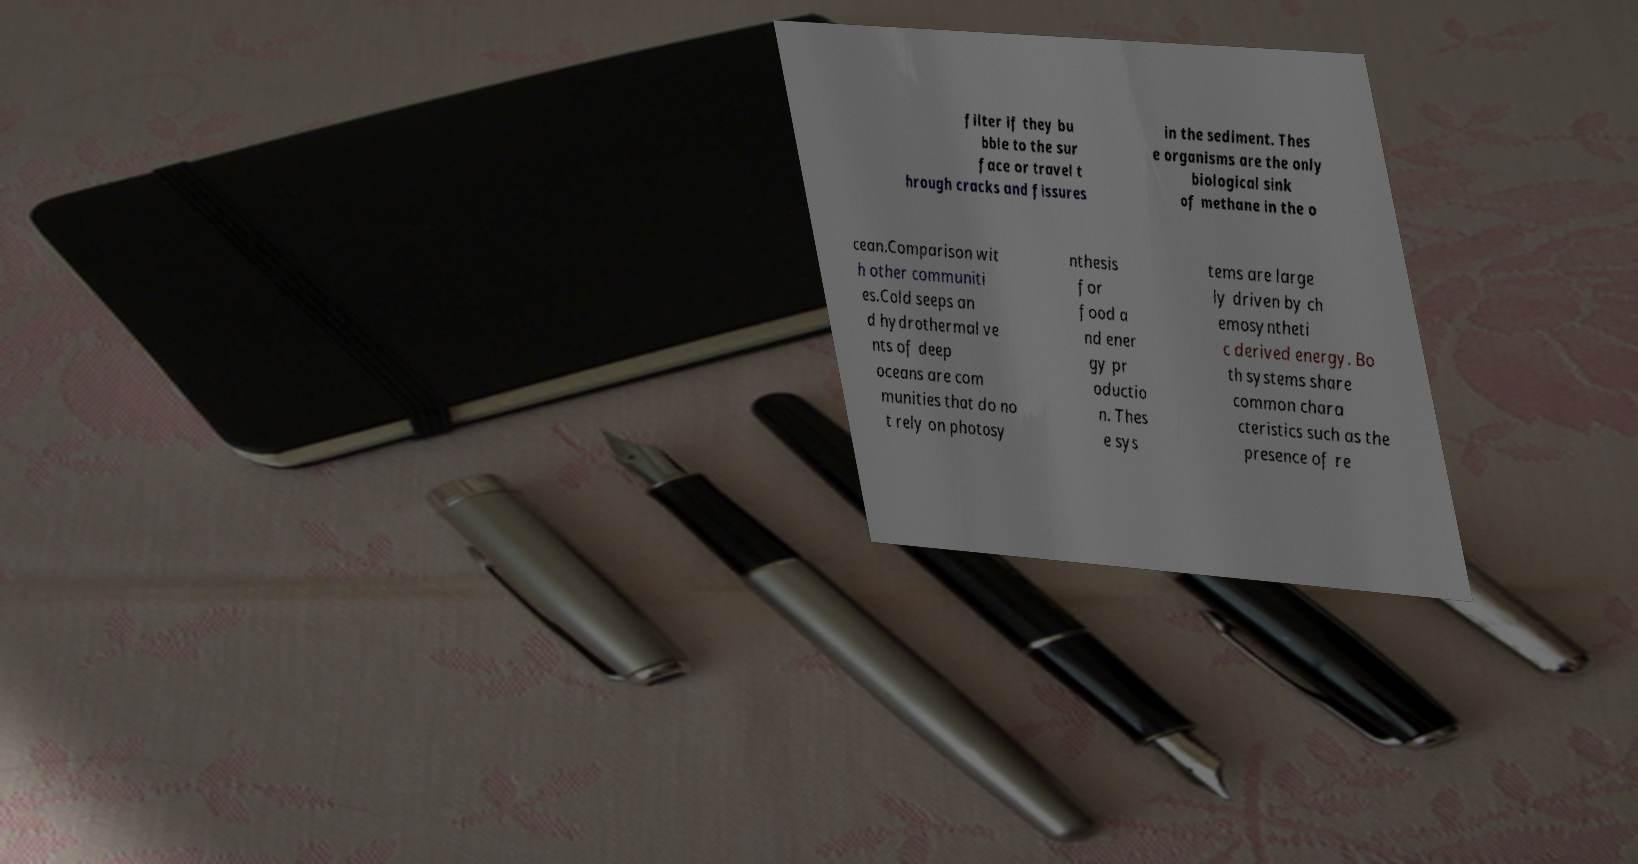What messages or text are displayed in this image? I need them in a readable, typed format. filter if they bu bble to the sur face or travel t hrough cracks and fissures in the sediment. Thes e organisms are the only biological sink of methane in the o cean.Comparison wit h other communiti es.Cold seeps an d hydrothermal ve nts of deep oceans are com munities that do no t rely on photosy nthesis for food a nd ener gy pr oductio n. Thes e sys tems are large ly driven by ch emosyntheti c derived energy. Bo th systems share common chara cteristics such as the presence of re 